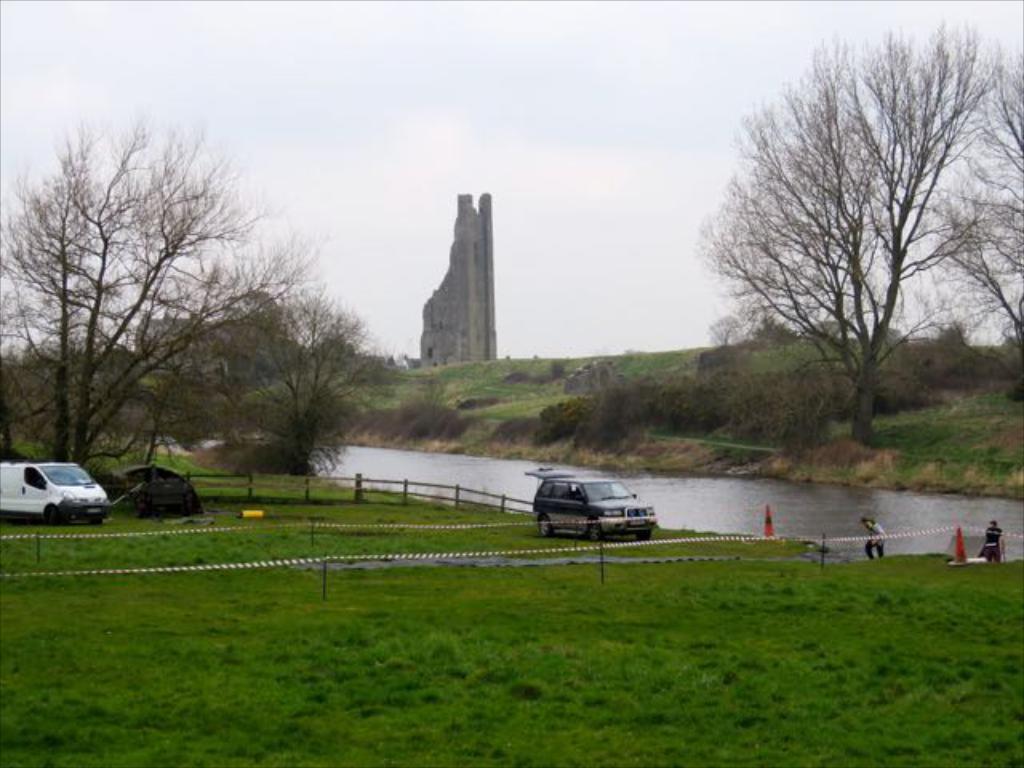Describe this image in one or two sentences. In this picture we can see there are two vehicles are parked on the path and on the path there is a fence, cone barriers and on the right side of the people there is a water, trees, an architecture and a cloudy sky. 